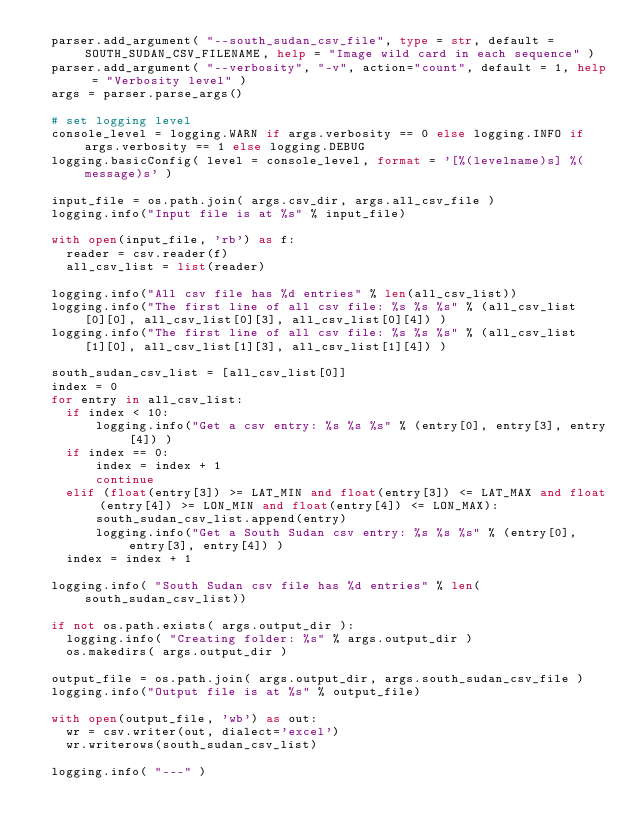Convert code to text. <code><loc_0><loc_0><loc_500><loc_500><_Python_>  parser.add_argument( "--south_sudan_csv_file", type = str, default = SOUTH_SUDAN_CSV_FILENAME, help = "Image wild card in each sequence" )
  parser.add_argument( "--verbosity", "-v", action="count", default = 1, help = "Verbosity level" )
  args = parser.parse_args()
    
  # set logging level 
  console_level = logging.WARN if args.verbosity == 0 else logging.INFO if args.verbosity == 1 else logging.DEBUG
  logging.basicConfig( level = console_level, format = '[%(levelname)s] %(message)s' )

  input_file = os.path.join( args.csv_dir, args.all_csv_file )
  logging.info("Input file is at %s" % input_file)

  with open(input_file, 'rb') as f:
    reader = csv.reader(f)
    all_csv_list = list(reader)

  logging.info("All csv file has %d entries" % len(all_csv_list))
  logging.info("The first line of all csv file: %s %s %s" % (all_csv_list[0][0], all_csv_list[0][3], all_csv_list[0][4]) )
  logging.info("The first line of all csv file: %s %s %s" % (all_csv_list[1][0], all_csv_list[1][3], all_csv_list[1][4]) )

  south_sudan_csv_list = [all_csv_list[0]]
  index = 0
  for entry in all_csv_list:
    if index < 10:
        logging.info("Get a csv entry: %s %s %s" % (entry[0], entry[3], entry[4]) )
    if index == 0:
        index = index + 1
        continue
    elif (float(entry[3]) >= LAT_MIN and float(entry[3]) <= LAT_MAX and float(entry[4]) >= LON_MIN and float(entry[4]) <= LON_MAX):
        south_sudan_csv_list.append(entry)
        logging.info("Get a South Sudan csv entry: %s %s %s" % (entry[0], entry[3], entry[4]) )
    index = index + 1

  logging.info( "South Sudan csv file has %d entries" % len(south_sudan_csv_list))

  if not os.path.exists( args.output_dir ):
    logging.info( "Creating folder: %s" % args.output_dir )
    os.makedirs( args.output_dir )

  output_file = os.path.join( args.output_dir, args.south_sudan_csv_file )
  logging.info("Output file is at %s" % output_file)

  with open(output_file, 'wb') as out:
    wr = csv.writer(out, dialect='excel')
    wr.writerows(south_sudan_csv_list)

  logging.info( "---" )
</code> 